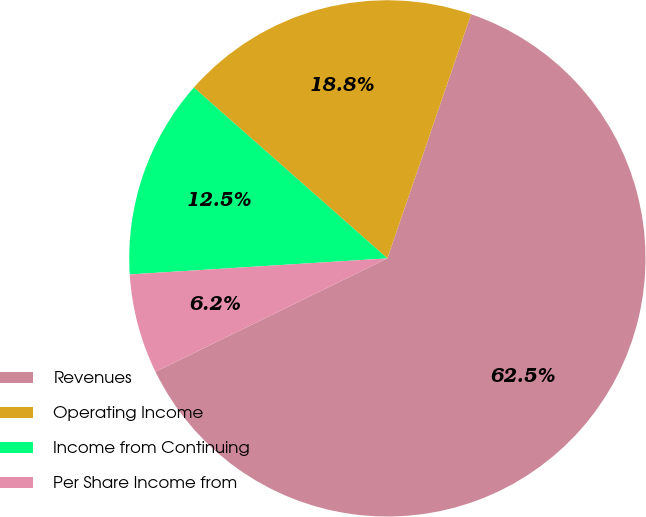Convert chart. <chart><loc_0><loc_0><loc_500><loc_500><pie_chart><fcel>Revenues<fcel>Operating Income<fcel>Income from Continuing<fcel>Per Share Income from<nl><fcel>62.5%<fcel>18.75%<fcel>12.5%<fcel>6.25%<nl></chart> 